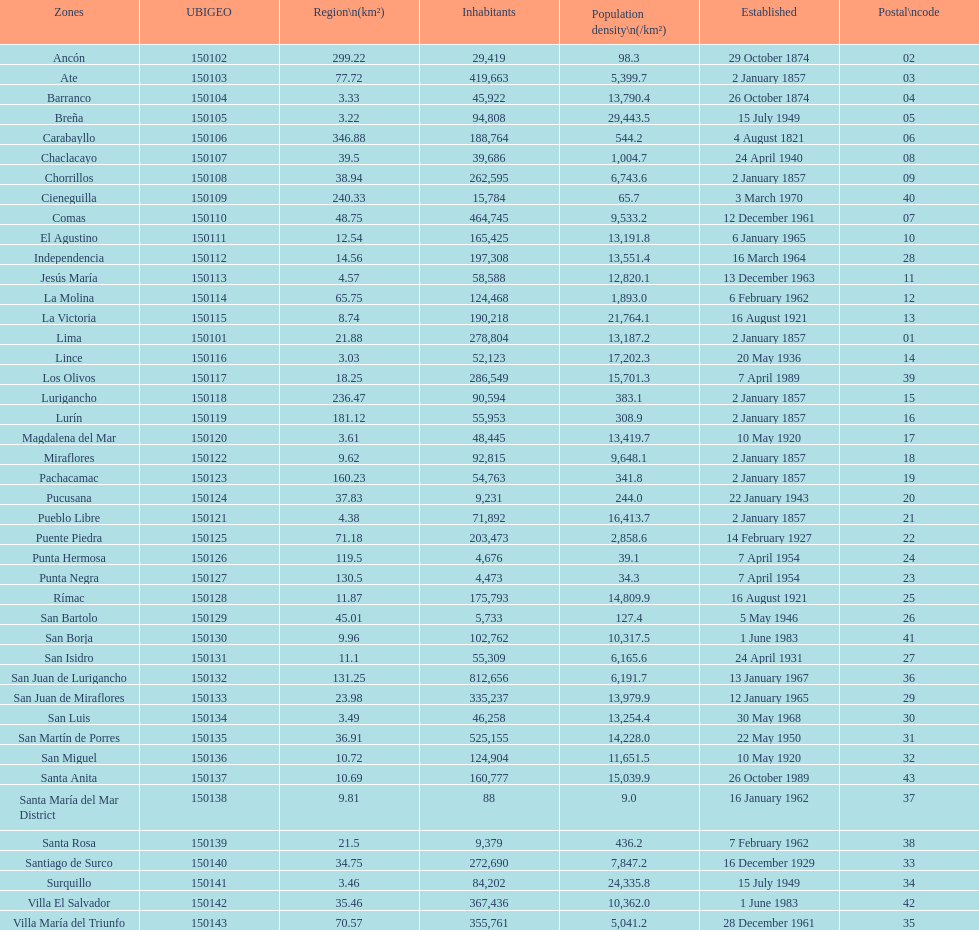What district has the least amount of population? Santa María del Mar District. 